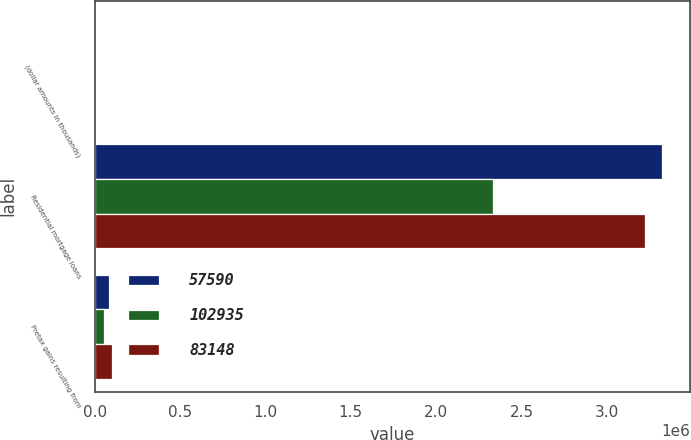<chart> <loc_0><loc_0><loc_500><loc_500><stacked_bar_chart><ecel><fcel>(dollar amounts in thousands)<fcel>Residential mortgage loans<fcel>Pretax gains resulting from<nl><fcel>57590<fcel>2015<fcel>3.32272e+06<fcel>83148<nl><fcel>102935<fcel>2014<fcel>2.33006e+06<fcel>57590<nl><fcel>83148<fcel>2013<fcel>3.22124e+06<fcel>102935<nl></chart> 